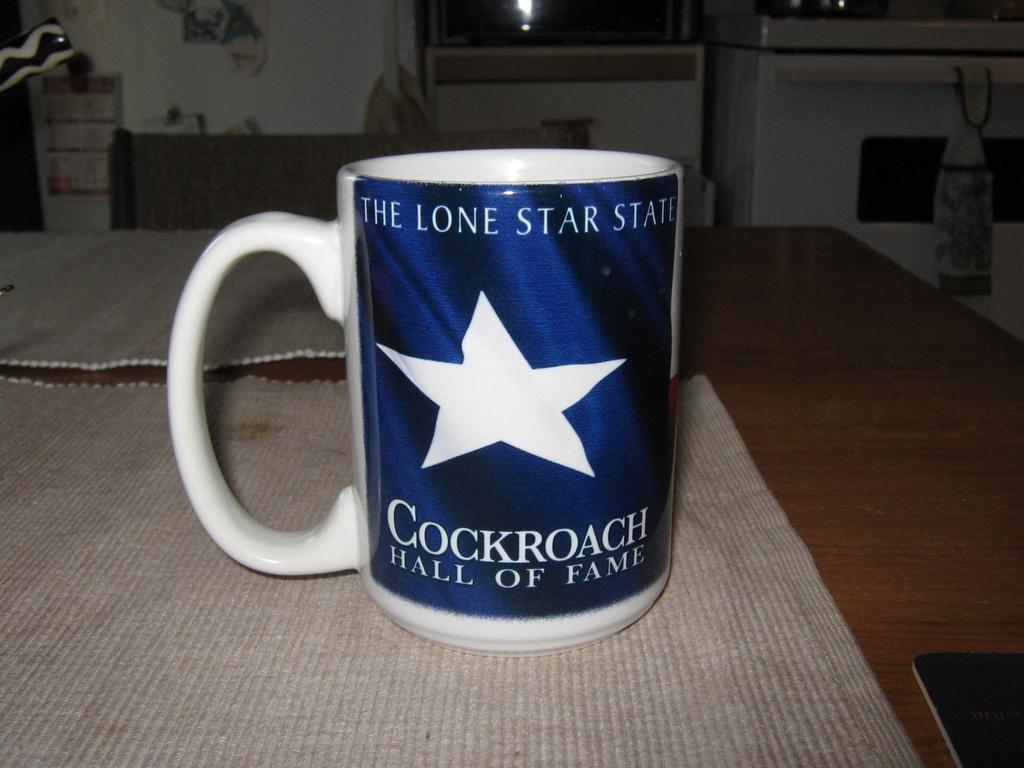<image>
Summarize the visual content of the image. A coffee mug is decorated with a white star and the words the Lone Star State. 